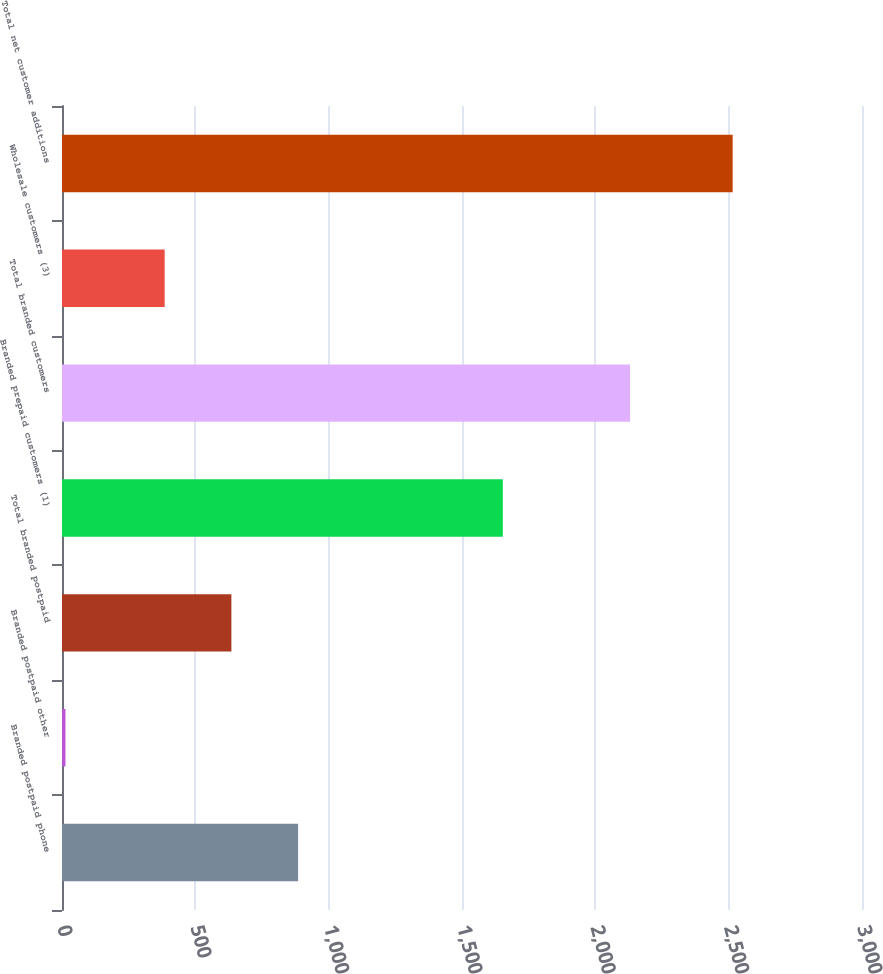<chart> <loc_0><loc_0><loc_500><loc_500><bar_chart><fcel>Branded postpaid phone<fcel>Branded postpaid other<fcel>Total branded postpaid<fcel>Branded prepaid customers (1)<fcel>Total branded customers<fcel>Wholesale customers (3)<fcel>Total net customer additions<nl><fcel>885.4<fcel>13<fcel>635.2<fcel>1653<fcel>2130<fcel>385<fcel>2515<nl></chart> 